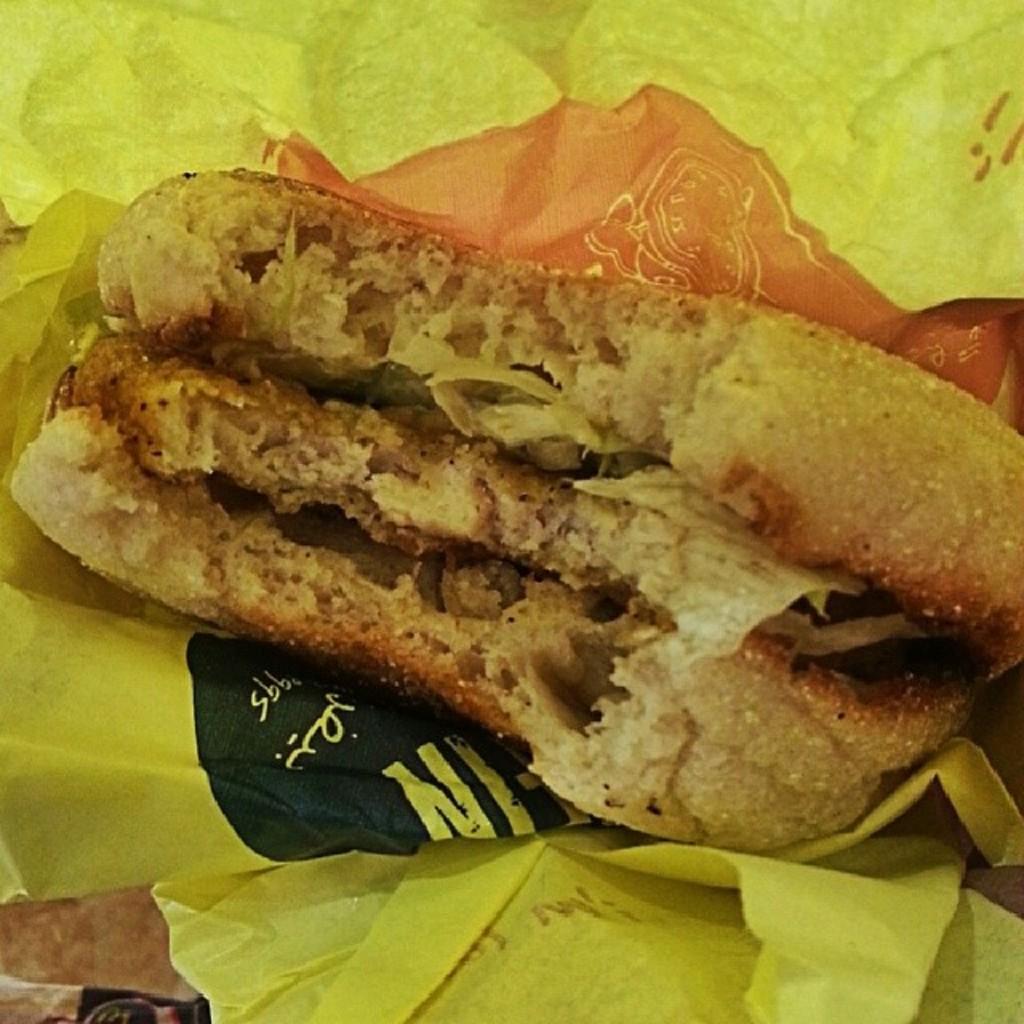How would you summarize this image in a sentence or two? In the center of the image we can see the yellow color paper. On the paper, we can see some food items. At the bottom left side of the image, we can see some object. 